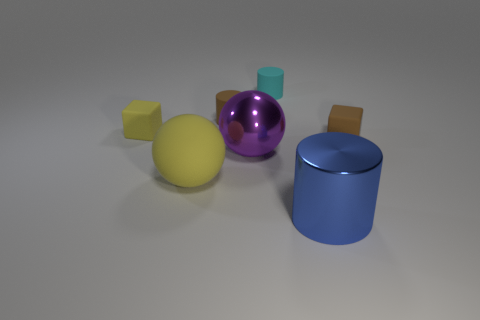There is a object behind the brown cylinder that is right of the big ball on the left side of the brown cylinder; how big is it?
Your answer should be compact. Small. There is a rubber block that is left of the brown cylinder; are there any blue cylinders that are behind it?
Your answer should be compact. No. Is the shape of the tiny yellow rubber object the same as the big metal thing that is in front of the large matte thing?
Provide a succinct answer. No. The cylinder in front of the large purple sphere is what color?
Offer a very short reply. Blue. What is the size of the rubber cube on the left side of the cylinder that is to the left of the purple shiny ball?
Your response must be concise. Small. Does the metal object to the right of the tiny cyan rubber object have the same shape as the small yellow rubber object?
Give a very brief answer. No. There is another small thing that is the same shape as the cyan thing; what material is it?
Your answer should be compact. Rubber. How many things are either big objects on the left side of the metal cylinder or things behind the big cylinder?
Offer a terse response. 6. Do the big rubber ball and the small rubber thing that is in front of the tiny yellow cube have the same color?
Provide a short and direct response. No. There is a large yellow thing that is the same material as the brown cylinder; what is its shape?
Make the answer very short. Sphere. 